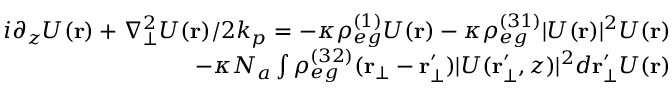Convert formula to latex. <formula><loc_0><loc_0><loc_500><loc_500>\begin{array} { r } { i { \partial _ { z } U ( r ) } + { \nabla _ { \bot } ^ { 2 } U ( r ) } / { 2 k _ { p } } = - \kappa \rho _ { e g } ^ { ( 1 ) } U ( r ) - \kappa \rho _ { e g } ^ { ( 3 1 ) } | U ( r ) | ^ { 2 } U ( r ) } \\ { - \kappa N _ { a } \int \rho _ { e g } ^ { ( 3 2 ) } ( r _ { \bot } - r _ { \bot } ^ { \prime } ) | U ( r _ { \bot } ^ { \prime } , z ) | ^ { 2 } d r _ { \bot } ^ { \prime } U ( r ) } \end{array}</formula> 